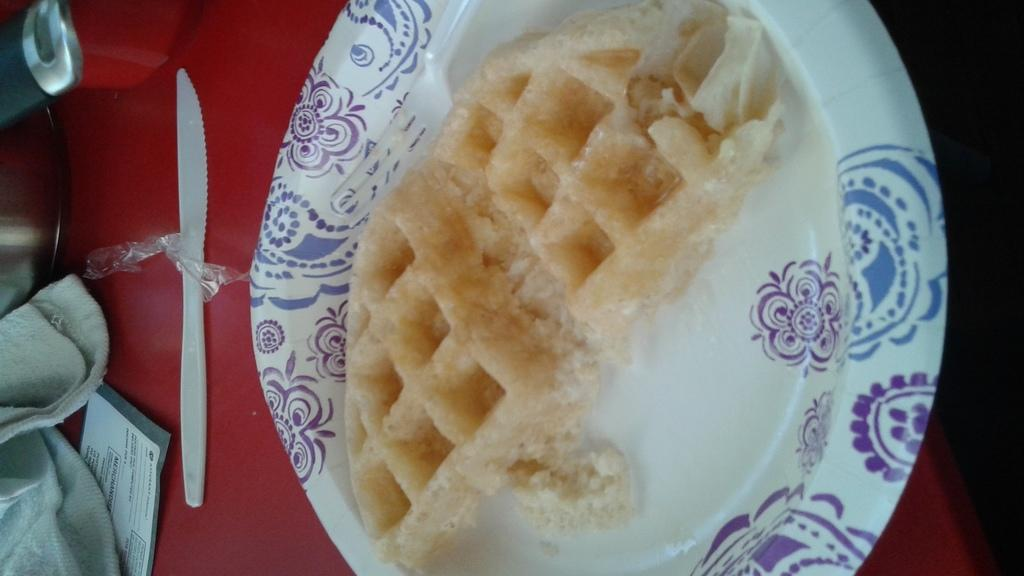What is the main object in the center of the image? There is a table in the center of the image. What is placed on the table? There is a vessel, a knife, a cloth, a paper, a plate containing a food item, and a fork on the table. What type of food item is on the plate? The provided facts do not specify the type of food item on the plate. What can be used to cut or slice the food item on the plate? There is a knife on the table that can be used to cut or slice the food item. How many planes are flying over the table in the image? There are no planes visible in the image; it only shows a table with various items on it. 